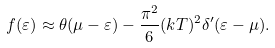Convert formula to latex. <formula><loc_0><loc_0><loc_500><loc_500>f ( \varepsilon ) \approx \theta ( \mu - \varepsilon ) - \frac { \pi ^ { 2 } } { 6 } ( k T ) ^ { 2 } \delta ^ { \prime } ( \varepsilon - \mu ) .</formula> 